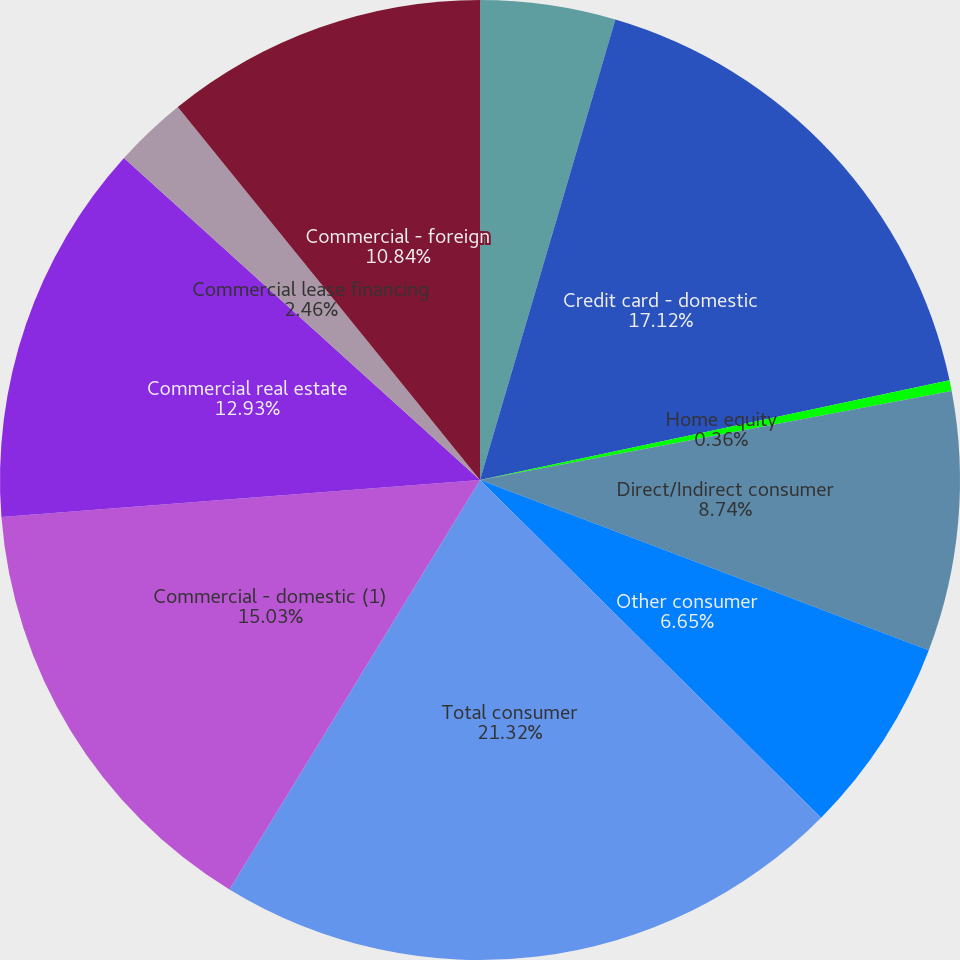Convert chart. <chart><loc_0><loc_0><loc_500><loc_500><pie_chart><fcel>Residential mortgage<fcel>Credit card - domestic<fcel>Home equity<fcel>Direct/Indirect consumer<fcel>Other consumer<fcel>Total consumer<fcel>Commercial - domestic (1)<fcel>Commercial real estate<fcel>Commercial lease financing<fcel>Commercial - foreign<nl><fcel>4.55%<fcel>17.12%<fcel>0.36%<fcel>8.74%<fcel>6.65%<fcel>21.32%<fcel>15.03%<fcel>12.93%<fcel>2.46%<fcel>10.84%<nl></chart> 